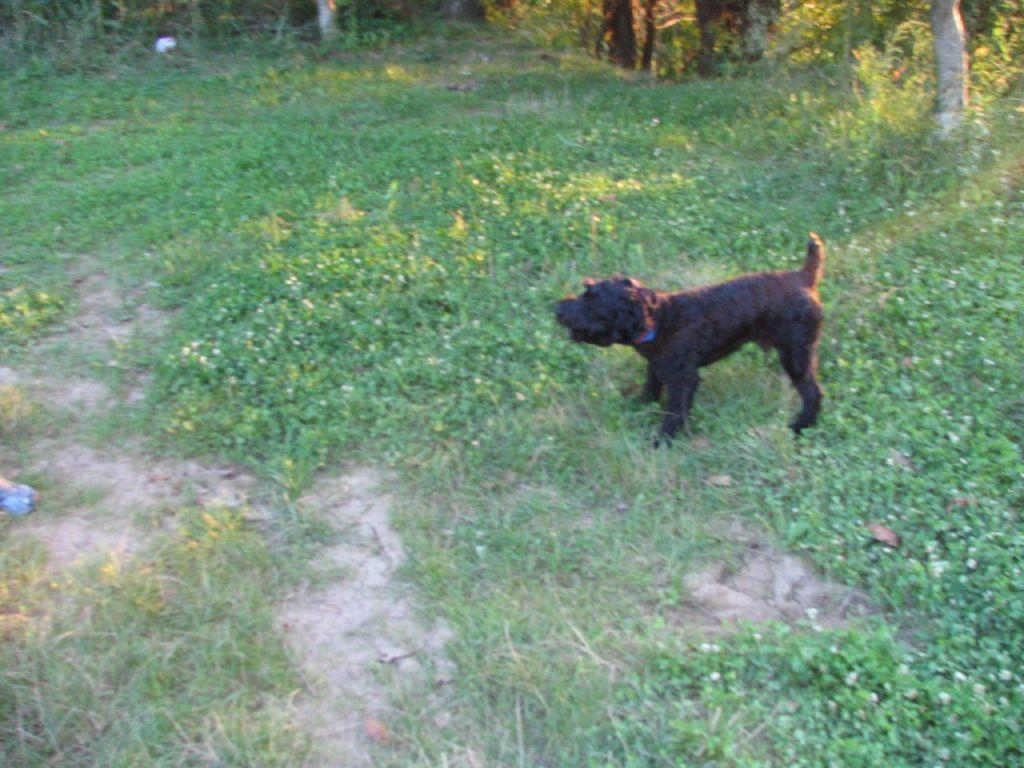What type of animal is present in the image? There is a dog in the image. What is the dog doing in the image? The dog is standing in the image. What is the color of the dog? The dog is black in color. What type of terrain is visible in the image? There is grass visible in the image. What can be seen in the background of the image? There are trees in the background of the image. How does the dog control the zephyr in the image? There is no mention of a zephyr or any control in the image; it simply shows a black dog standing on grass with trees in the background. 